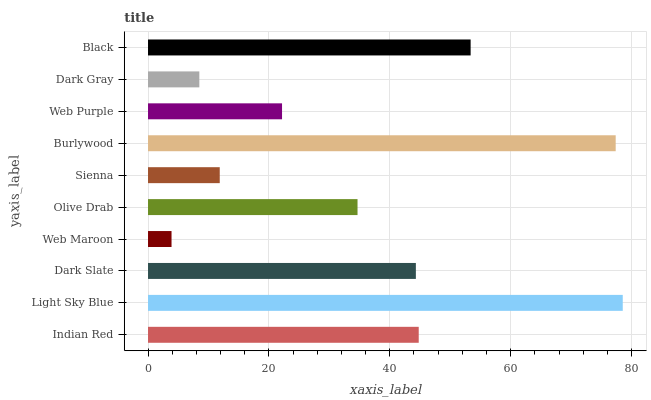Is Web Maroon the minimum?
Answer yes or no. Yes. Is Light Sky Blue the maximum?
Answer yes or no. Yes. Is Dark Slate the minimum?
Answer yes or no. No. Is Dark Slate the maximum?
Answer yes or no. No. Is Light Sky Blue greater than Dark Slate?
Answer yes or no. Yes. Is Dark Slate less than Light Sky Blue?
Answer yes or no. Yes. Is Dark Slate greater than Light Sky Blue?
Answer yes or no. No. Is Light Sky Blue less than Dark Slate?
Answer yes or no. No. Is Dark Slate the high median?
Answer yes or no. Yes. Is Olive Drab the low median?
Answer yes or no. Yes. Is Web Purple the high median?
Answer yes or no. No. Is Dark Gray the low median?
Answer yes or no. No. 